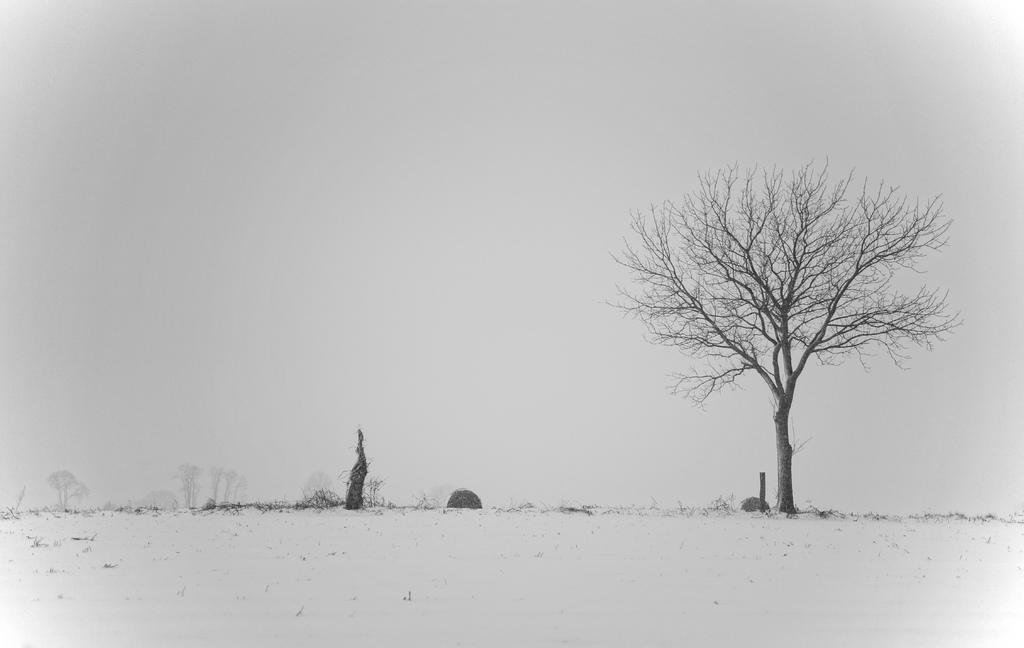What is the color scheme of the image? The image is black and white. What type of trees can be seen in the image? There are bare trees in the image. What else can be found on the ground in the image? There are plants on the ground in the image. What is visible in the background of the image? The sky is visible in the image. Can you tell me how many giraffes are visible in the image? There are no giraffes present in the image; it features bare trees and plants on the ground. What type of print can be seen on the plants in the image? There is no print visible on the plants in the image; they are simply depicted as plants. 